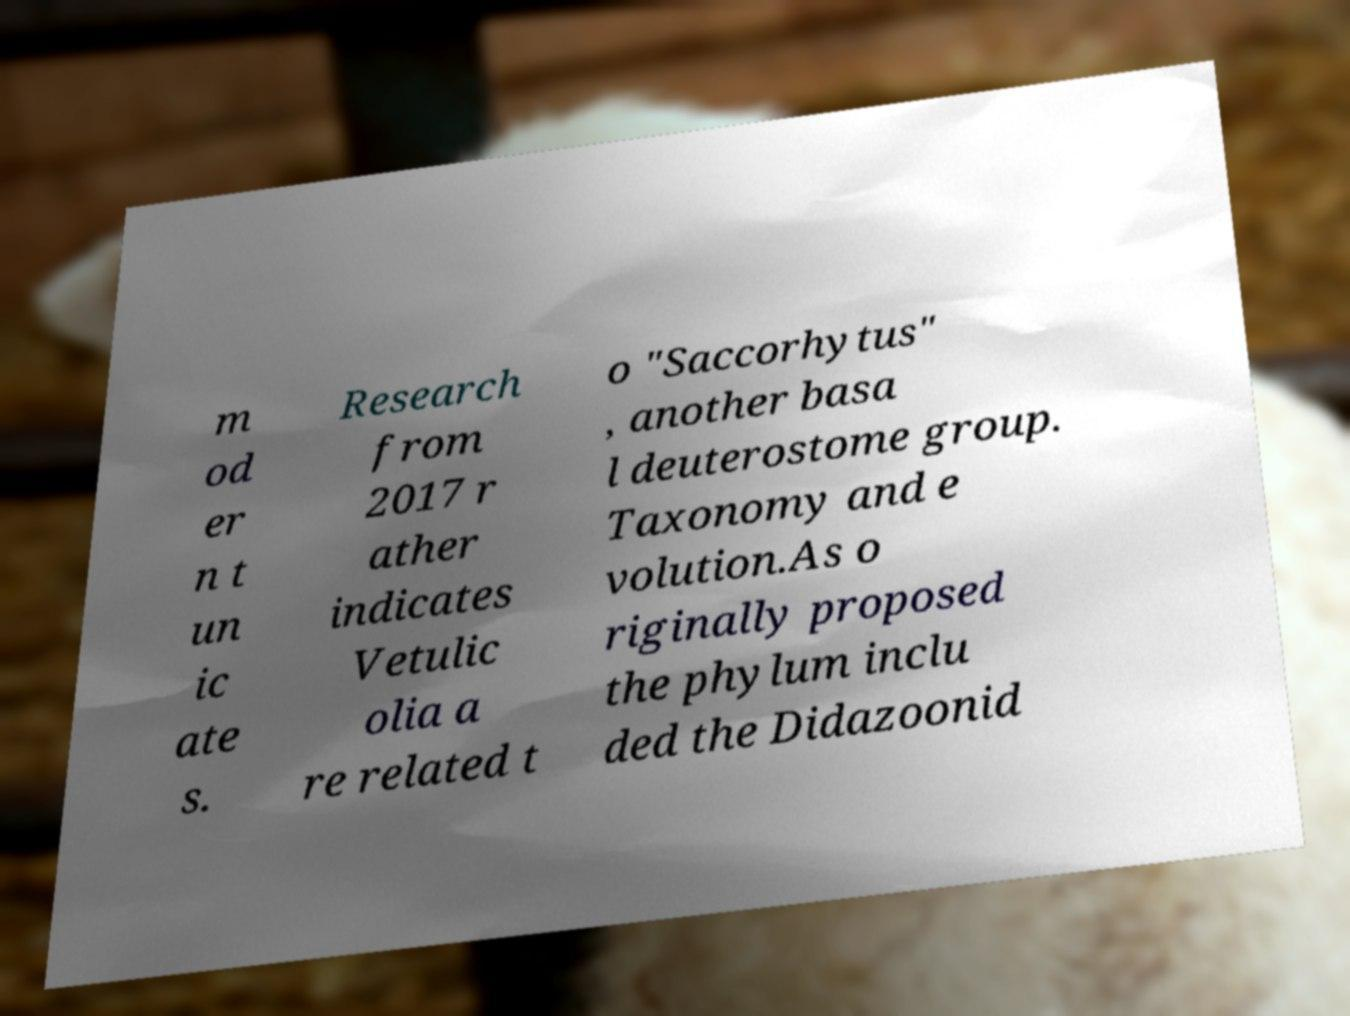Please read and relay the text visible in this image. What does it say? m od er n t un ic ate s. Research from 2017 r ather indicates Vetulic olia a re related t o "Saccorhytus" , another basa l deuterostome group. Taxonomy and e volution.As o riginally proposed the phylum inclu ded the Didazoonid 